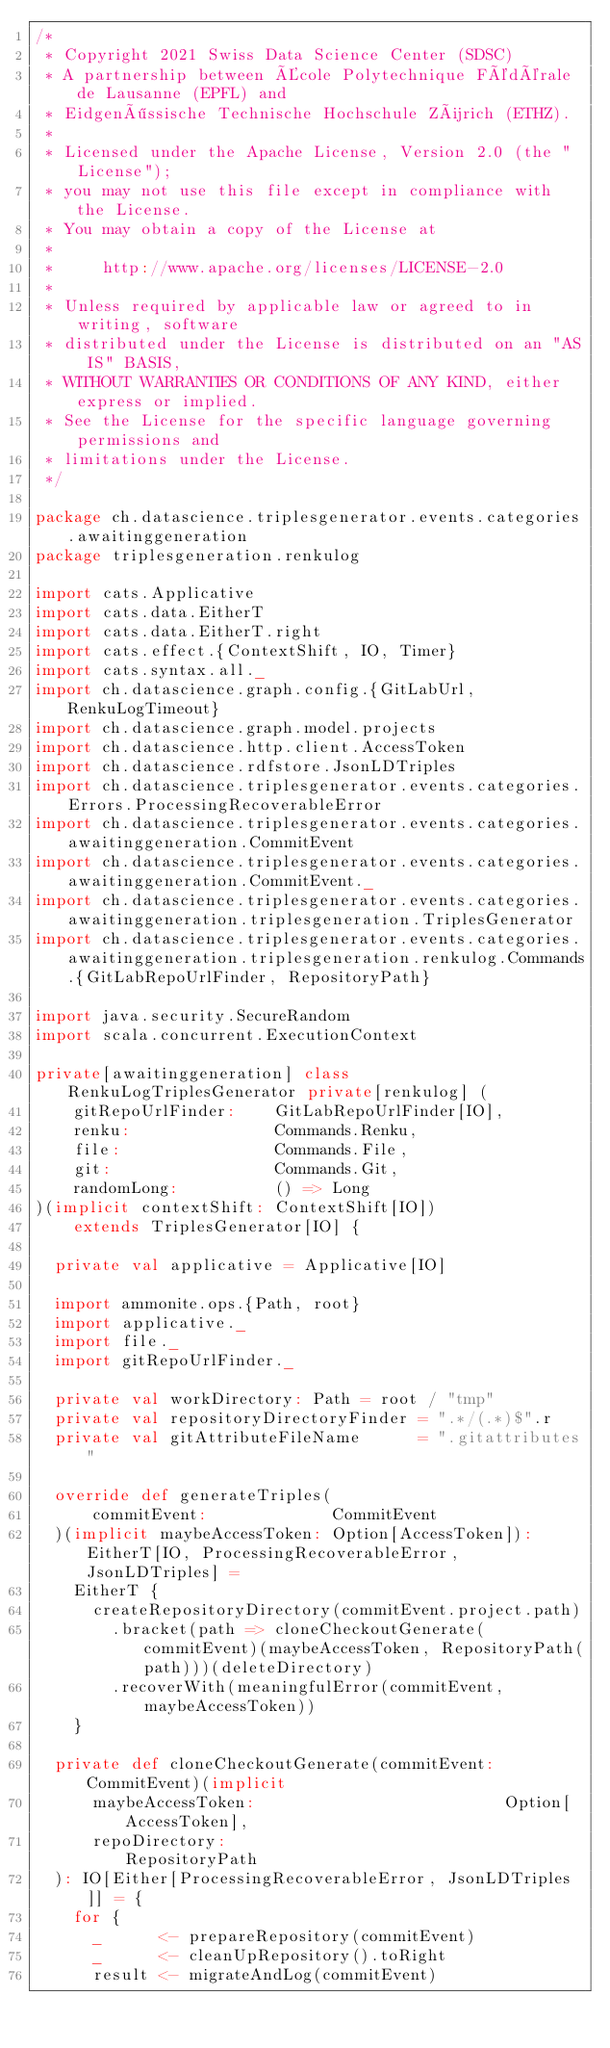Convert code to text. <code><loc_0><loc_0><loc_500><loc_500><_Scala_>/*
 * Copyright 2021 Swiss Data Science Center (SDSC)
 * A partnership between École Polytechnique Fédérale de Lausanne (EPFL) and
 * Eidgenössische Technische Hochschule Zürich (ETHZ).
 *
 * Licensed under the Apache License, Version 2.0 (the "License");
 * you may not use this file except in compliance with the License.
 * You may obtain a copy of the License at
 *
 *     http://www.apache.org/licenses/LICENSE-2.0
 *
 * Unless required by applicable law or agreed to in writing, software
 * distributed under the License is distributed on an "AS IS" BASIS,
 * WITHOUT WARRANTIES OR CONDITIONS OF ANY KIND, either express or implied.
 * See the License for the specific language governing permissions and
 * limitations under the License.
 */

package ch.datascience.triplesgenerator.events.categories.awaitinggeneration
package triplesgeneration.renkulog

import cats.Applicative
import cats.data.EitherT
import cats.data.EitherT.right
import cats.effect.{ContextShift, IO, Timer}
import cats.syntax.all._
import ch.datascience.graph.config.{GitLabUrl, RenkuLogTimeout}
import ch.datascience.graph.model.projects
import ch.datascience.http.client.AccessToken
import ch.datascience.rdfstore.JsonLDTriples
import ch.datascience.triplesgenerator.events.categories.Errors.ProcessingRecoverableError
import ch.datascience.triplesgenerator.events.categories.awaitinggeneration.CommitEvent
import ch.datascience.triplesgenerator.events.categories.awaitinggeneration.CommitEvent._
import ch.datascience.triplesgenerator.events.categories.awaitinggeneration.triplesgeneration.TriplesGenerator
import ch.datascience.triplesgenerator.events.categories.awaitinggeneration.triplesgeneration.renkulog.Commands.{GitLabRepoUrlFinder, RepositoryPath}

import java.security.SecureRandom
import scala.concurrent.ExecutionContext

private[awaitinggeneration] class RenkuLogTriplesGenerator private[renkulog] (
    gitRepoUrlFinder:    GitLabRepoUrlFinder[IO],
    renku:               Commands.Renku,
    file:                Commands.File,
    git:                 Commands.Git,
    randomLong:          () => Long
)(implicit contextShift: ContextShift[IO])
    extends TriplesGenerator[IO] {

  private val applicative = Applicative[IO]

  import ammonite.ops.{Path, root}
  import applicative._
  import file._
  import gitRepoUrlFinder._

  private val workDirectory: Path = root / "tmp"
  private val repositoryDirectoryFinder = ".*/(.*)$".r
  private val gitAttributeFileName      = ".gitattributes"

  override def generateTriples(
      commitEvent:             CommitEvent
  )(implicit maybeAccessToken: Option[AccessToken]): EitherT[IO, ProcessingRecoverableError, JsonLDTriples] =
    EitherT {
      createRepositoryDirectory(commitEvent.project.path)
        .bracket(path => cloneCheckoutGenerate(commitEvent)(maybeAccessToken, RepositoryPath(path)))(deleteDirectory)
        .recoverWith(meaningfulError(commitEvent, maybeAccessToken))
    }

  private def cloneCheckoutGenerate(commitEvent: CommitEvent)(implicit
      maybeAccessToken:                          Option[AccessToken],
      repoDirectory:                             RepositoryPath
  ): IO[Either[ProcessingRecoverableError, JsonLDTriples]] = {
    for {
      _      <- prepareRepository(commitEvent)
      _      <- cleanUpRepository().toRight
      result <- migrateAndLog(commitEvent)</code> 